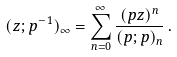<formula> <loc_0><loc_0><loc_500><loc_500>( z ; p ^ { - 1 } ) _ { \infty } = \sum _ { n = 0 } ^ { \infty } \frac { ( p z ) ^ { n } } { ( p ; p ) _ { n } } \, .</formula> 